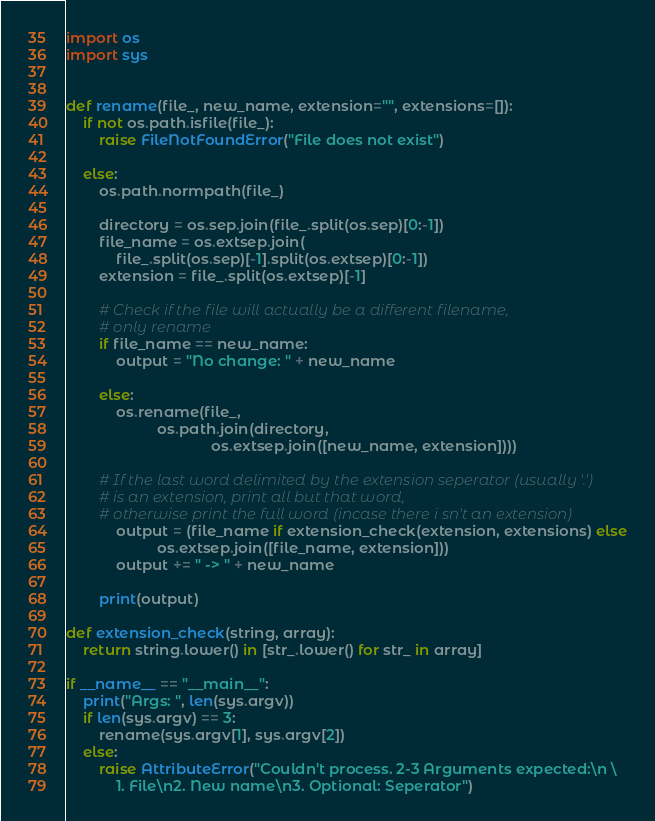Convert code to text. <code><loc_0><loc_0><loc_500><loc_500><_Python_>import os
import sys


def rename(file_, new_name, extension="", extensions=[]):
    if not os.path.isfile(file_):
        raise FileNotFoundError("File does not exist")

    else:
        os.path.normpath(file_)

        directory = os.sep.join(file_.split(os.sep)[0:-1])
        file_name = os.extsep.join(
            file_.split(os.sep)[-1].split(os.extsep)[0:-1])
        extension = file_.split(os.extsep)[-1]

        # Check if the file will actually be a different filename,
        # only rename
        if file_name == new_name:
            output = "No change: " + new_name

        else:
            os.rename(file_,
                      os.path.join(directory,
                                   os.extsep.join([new_name, extension])))

        # If the last word delimited by the extension seperator (usually '.')
        # is an extension, print all but that word,
        # otherwise print the full word (incase there i sn't an extension)
            output = (file_name if extension_check(extension, extensions) else
                      os.extsep.join([file_name, extension]))
            output += " -> " + new_name

        print(output)

def extension_check(string, array):
    return string.lower() in [str_.lower() for str_ in array]

if __name__ == "__main__":
    print("Args: ", len(sys.argv))
    if len(sys.argv) == 3:
        rename(sys.argv[1], sys.argv[2])
    else:
        raise AttributeError("Couldn't process. 2-3 Arguments expected:\n \
            1. File\n2. New name\n3. Optional: Seperator")
</code> 